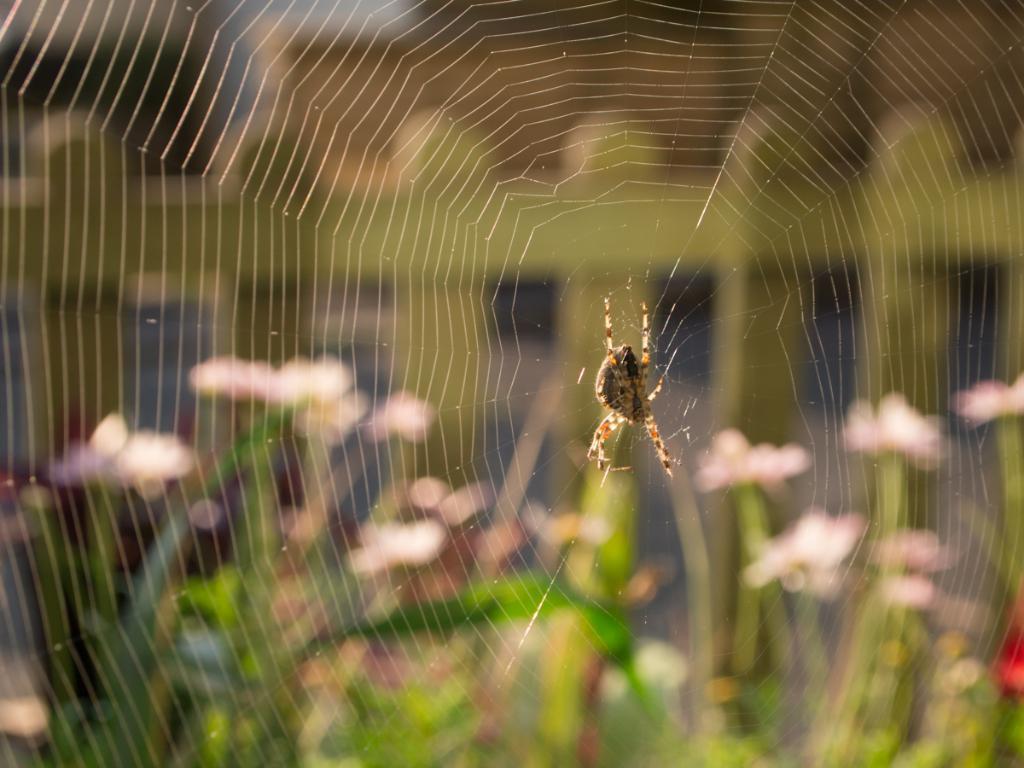Could you give a brief overview of what you see in this image? In this image I can see a spider on a web. The background is blurred. 